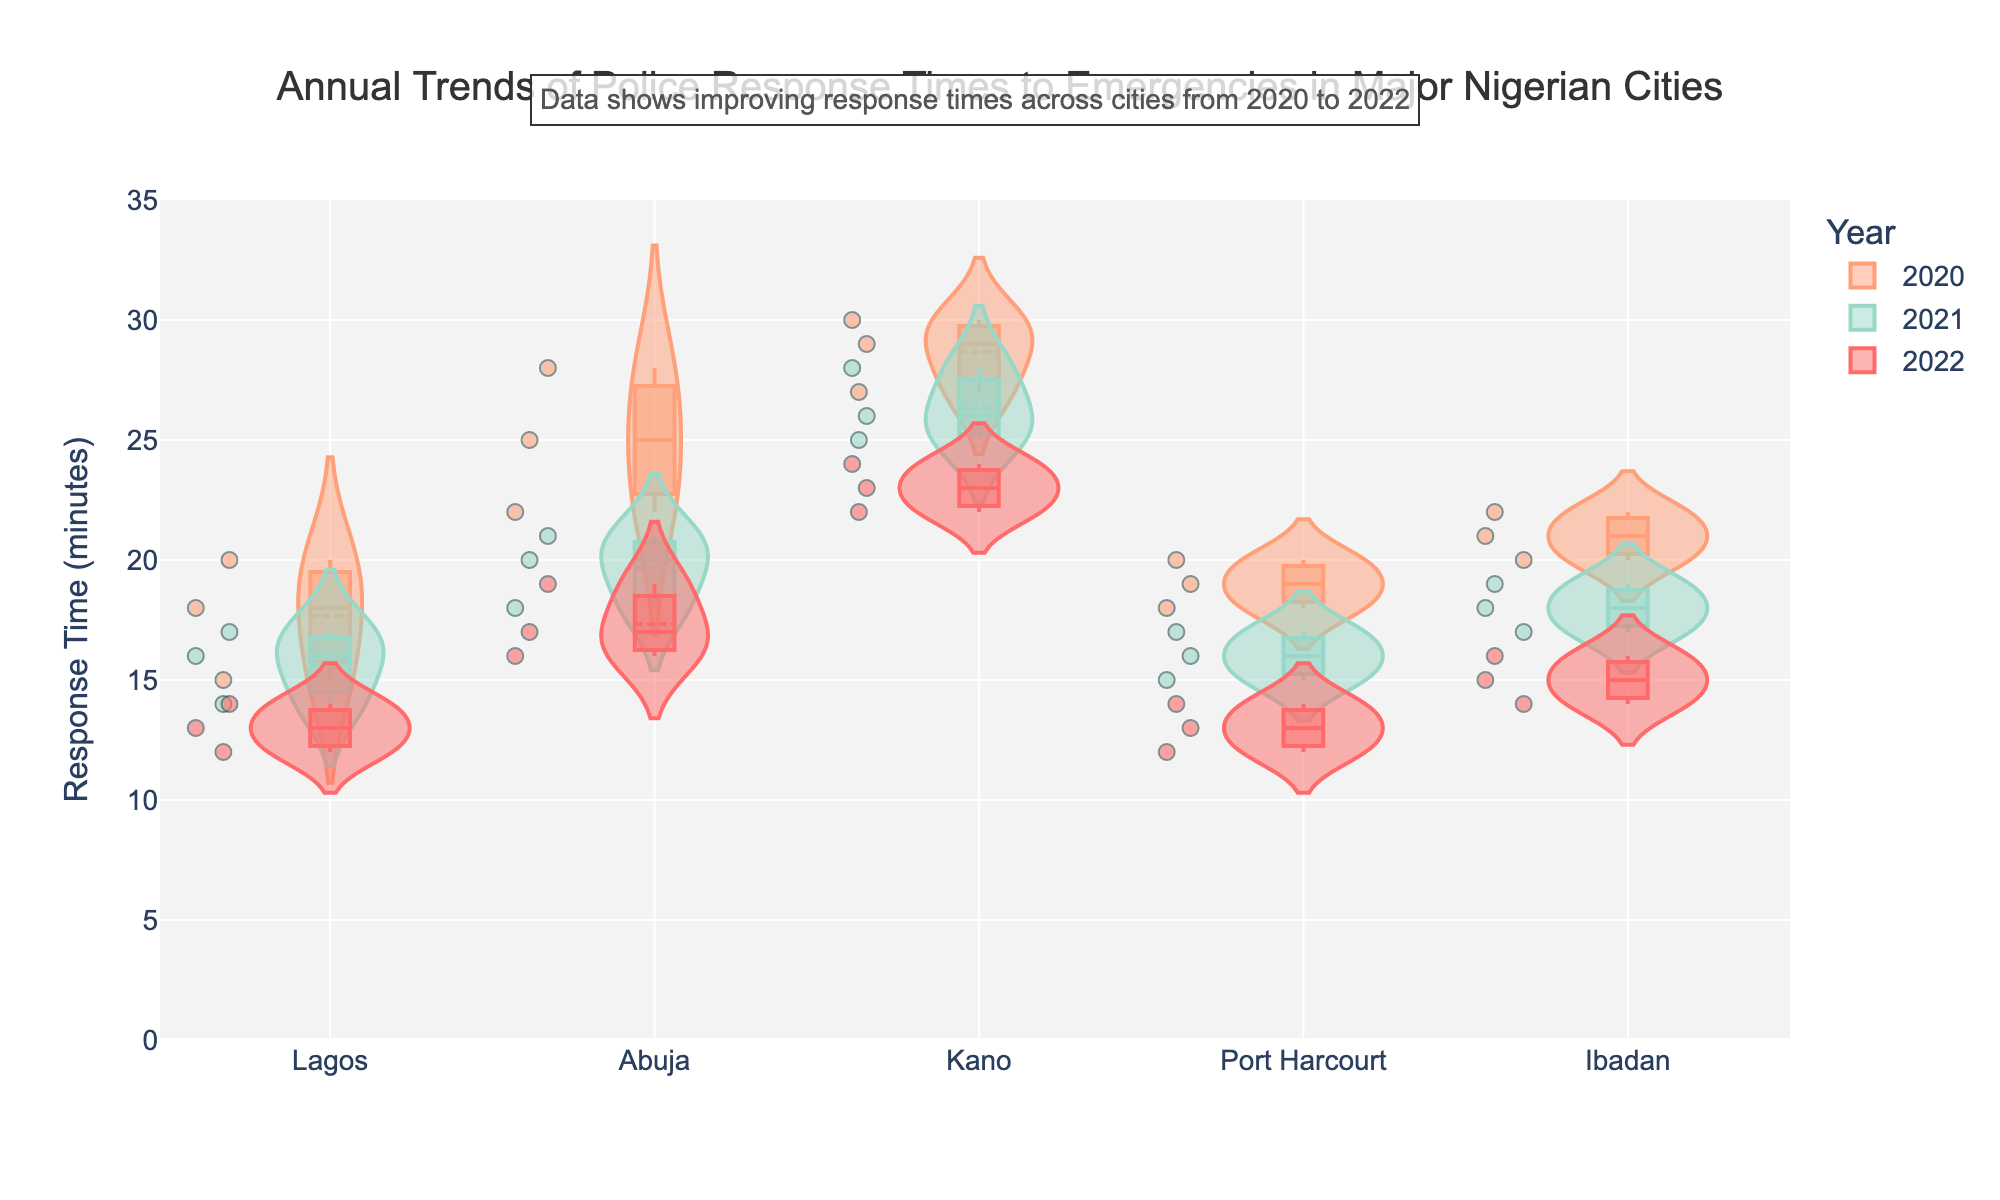What is the title of the figure? The title is usually located at the top of the figure. In this case, it reads "Annual Trends of Police Response Times to Emergencies in Major Nigerian Cities".
Answer: Annual Trends of Police Response Times to Emergencies in Major Nigerian Cities What is the average police response time in Lagos for the year 2020? To find the average, sum up the response times in Lagos for 2020 (15, 20, 18) and divide by the number of data points. (15 + 20 + 18) / 3 = 53 / 3 = 17.67
Answer: 17.67 Which city had the most improvement in police response time from 2020 to 2022? Comparing the response times for each city, calculate the difference in average response times from 2020 to 2022. For Lagos: (15+20+18)/3 - (13+12+14)/3 = 17.67 - 13 = 4.67. Repeat for other cities and find the city with the largest reduction. Lagos shows the largest improvement with a reduction of 4.67 minutes.
Answer: Lagos What is the trend of the police response time in Abuja from 2020 to 2022? Observing the jittered points and the density of the violin plots for Abuja, you can see that response times decreased each year from 2020 (25, 22, 28) to 2021 (20, 18, 21) to 2022 (19, 17, 16). This indicates an improving trend.
Answer: Improvement Which year has the highest variance in police response time across all cities? Examining the width of the violin plots for each year, wider plots indicate higher variance. The year 2020 shows the widest plots consistently across cities, hence the highest variance in response times.
Answer: 2020 What is the median police response time in Kano for the year 2022? The median is the middle value when data points are ordered. For Kano in 2022, the response times are (22, 23, 24). The median is the middle value, which is 23.
Answer: 23 Comparing Lagos and Port Harcourt in 2022, which city had better police response times? By observing the violin plots for Lagos and Port Harcourt in 2022, we note that the distribution of response times for Port Harcourt (12, 13, 14) is generally lower than Lagos (12, 13, 14). Thus, Port Harcourt had better response times.
Answer: Port Harcourt What color represents the year 2021 in the figure? Referring to the color legend, the color assigned to 2021 is '#4ECDC4', a shade of teal. The plots for 2021 are in teal.
Answer: Teal How do police response times in Ibadan change from 2021 to 2022? Observing the distribution and jittered points in Ibadan, response times appear to decrease from 2021 (19, 18, 17) to 2022 (16, 15, 14). This shows an improvement.
Answer: Improvement 